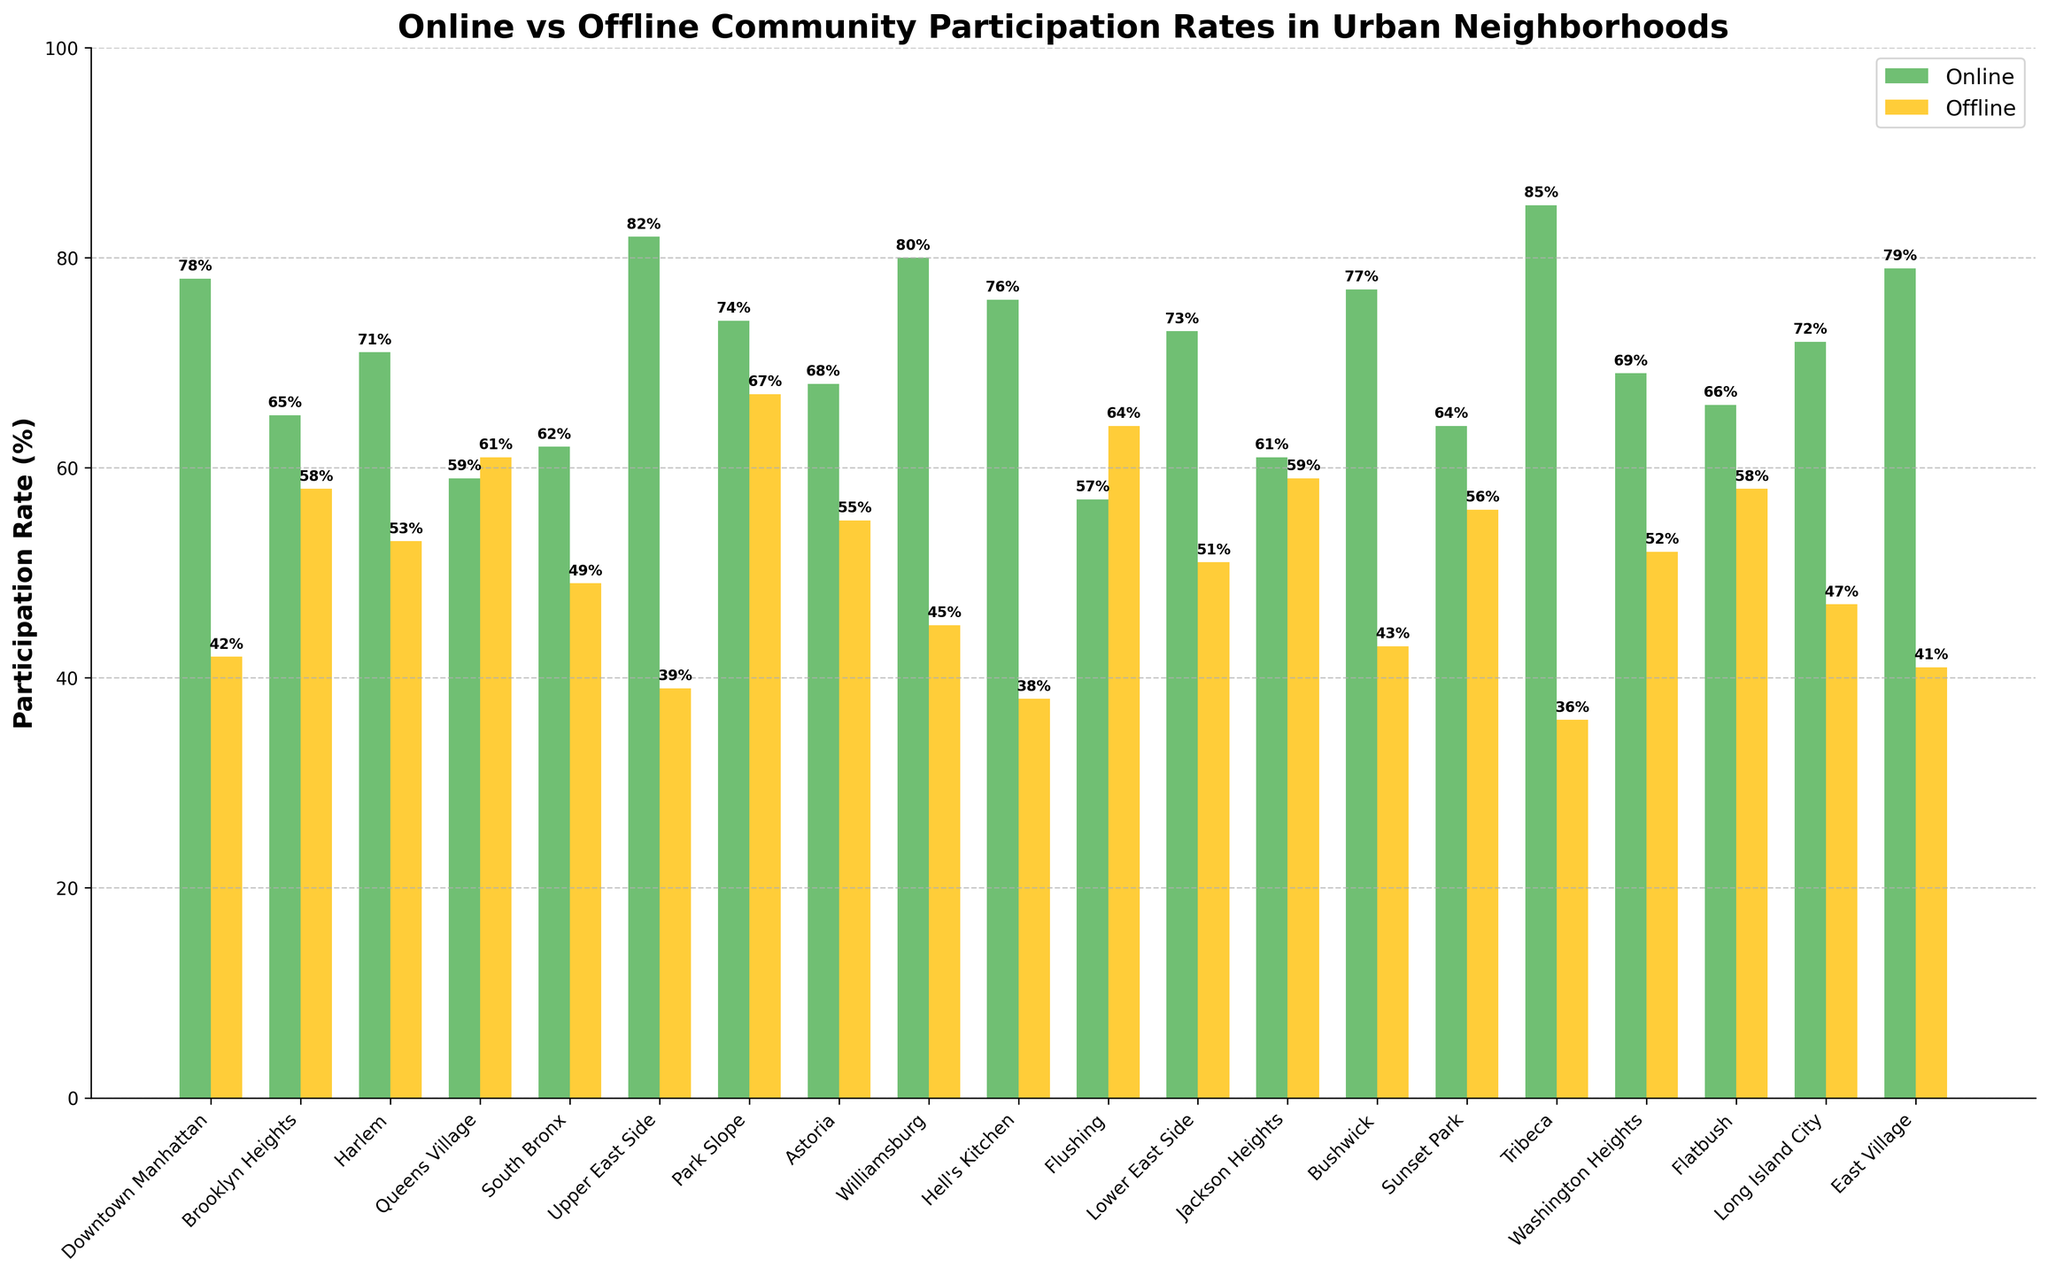What neighborhood has the highest online participation rate? The bar for Tribeca (85%) is the tallest among all bars in the online category.
Answer: Tribeca Which neighborhood has a higher offline participation rate, Downtown Manhattan or Flushing? Flushing's offline participation rate (64%) is higher than Downtown Manhattan's (42%) as indicated by the height of the respective bars.
Answer: Flushing What is the difference between online and offline participation rates in Williamsburg? The online participation rate for Williamsburg is 80% and the offline rate is 45%, the difference is 80 - 45 = 35%.
Answer: 35% Which neighborhood has both online and offline participation rates above 65%? Both rates are above 65% for Park Slope with online at 74% and offline at 67%.
Answer: Park Slope What is the average offline participation rate in Queens Village, Upper East Side, and Park Slope? Add the offline rates: 61% (Queens Village), 39% (Upper East Side), 67% (Park Slope). Total is 61 + 39 + 67 = 167%. The average is 167 / 3 = 55.67%.
Answer: 55.67% Which neighborhood shows the largest gap between online and offline participation rates? Tribeca has the online rate (85%) and offline rate (36%), the largest gap being 85 - 36 = 49%.
Answer: Tribeca What is the sum of offline participation rates in Harlem and Astoria? Harlem's offline rate is 53% and Astoria's is 55%. The sum is 53 + 55 = 108%.
Answer: 108% Do more neighborhoods have higher online participation rates than offline? 12 neighborhoods have higher online participation rates while 8 have higher offline rates.
Answer: Yes Which neighborhoods have an offline participation rate above 50% and a lower online rate than Downtown Manhattan? The neighborhoods are Flushing (57%), Queens Village (61%), Jackson Heights (61%), Sunset Park (64%), and Brooklyn Heights (58%).
Answer: Flushing, Queens Village, Jackson Heights, Sunset Park, Brooklyn Heights 